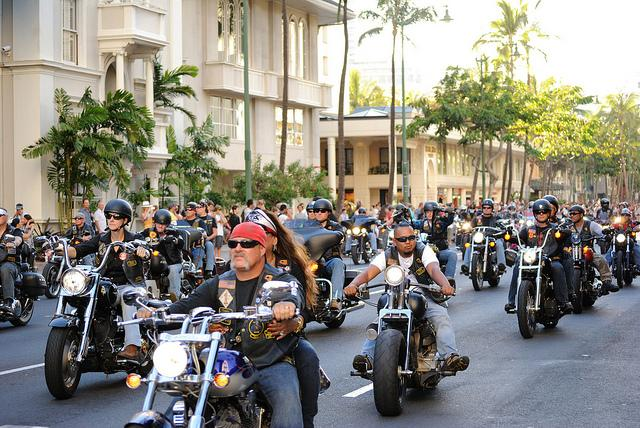What is the main reason hundreds of bikers would be riding together down a main street?

Choices:
A) conserve gas
B) safest route
C) short cut
D) attention attention 